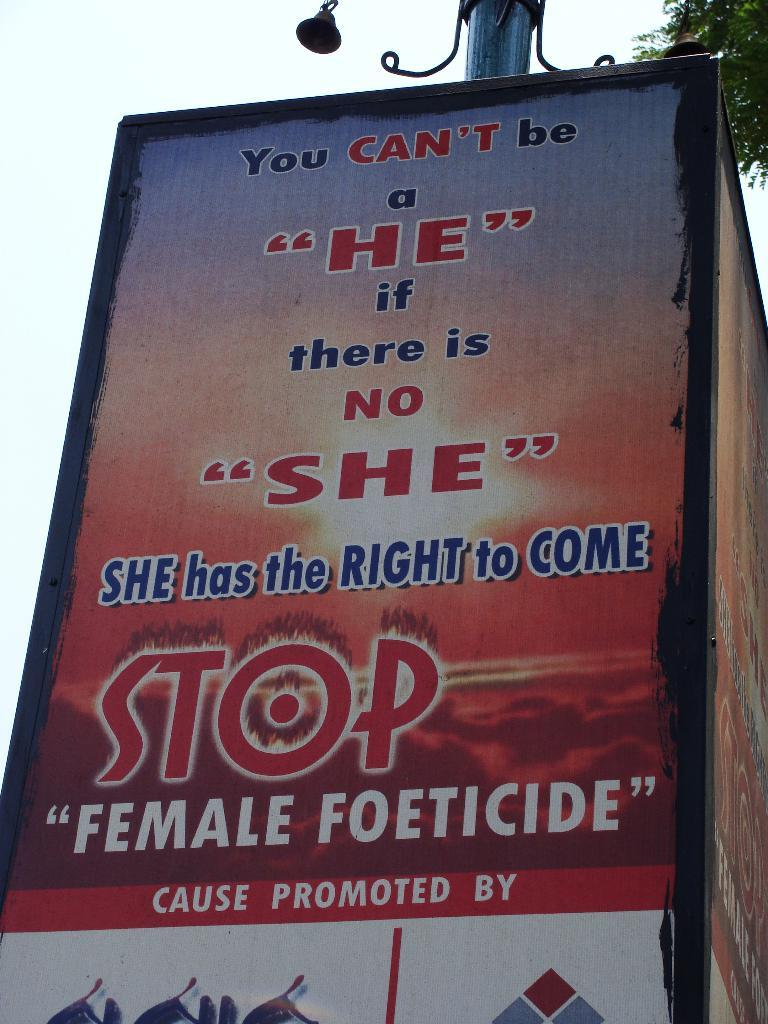<image>
Relay a brief, clear account of the picture shown. A powerful message to stop Female Foeticide is shown on this sign. 